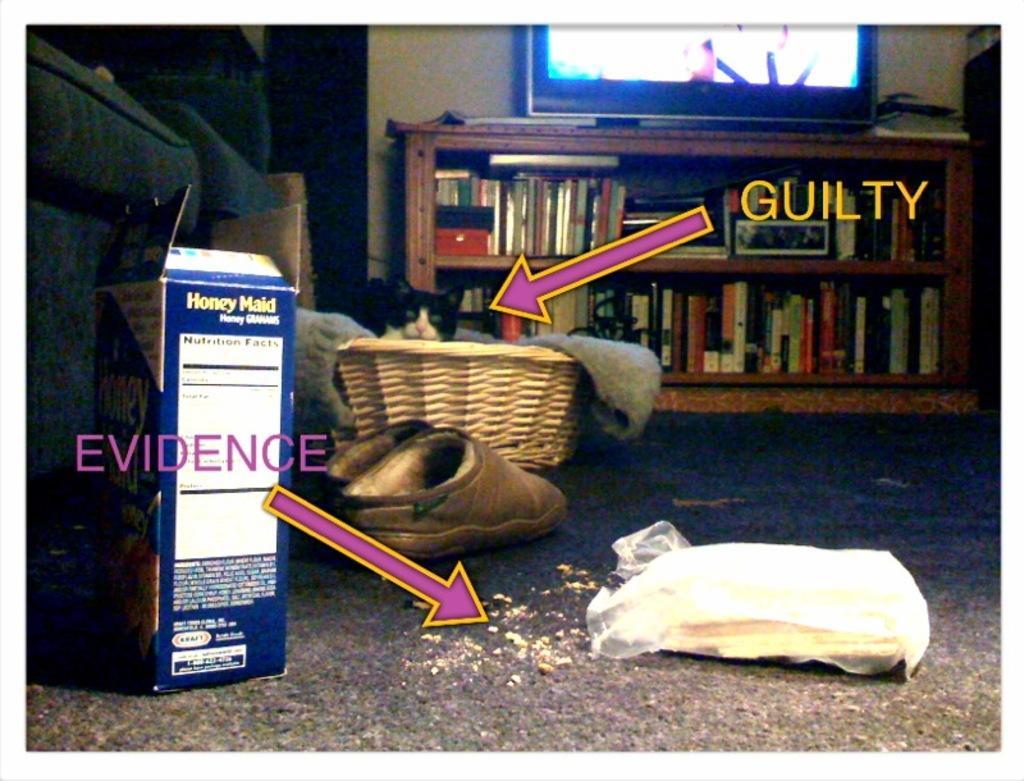Please provide a concise description of this image. In this image we can see a cat in a basket, shoes, a cover, arrow symbols, a text, books arranged in the racks, a television and a box. 